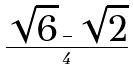<formula> <loc_0><loc_0><loc_500><loc_500>\frac { \sqrt { 6 } - \sqrt { 2 } } { 4 }</formula> 